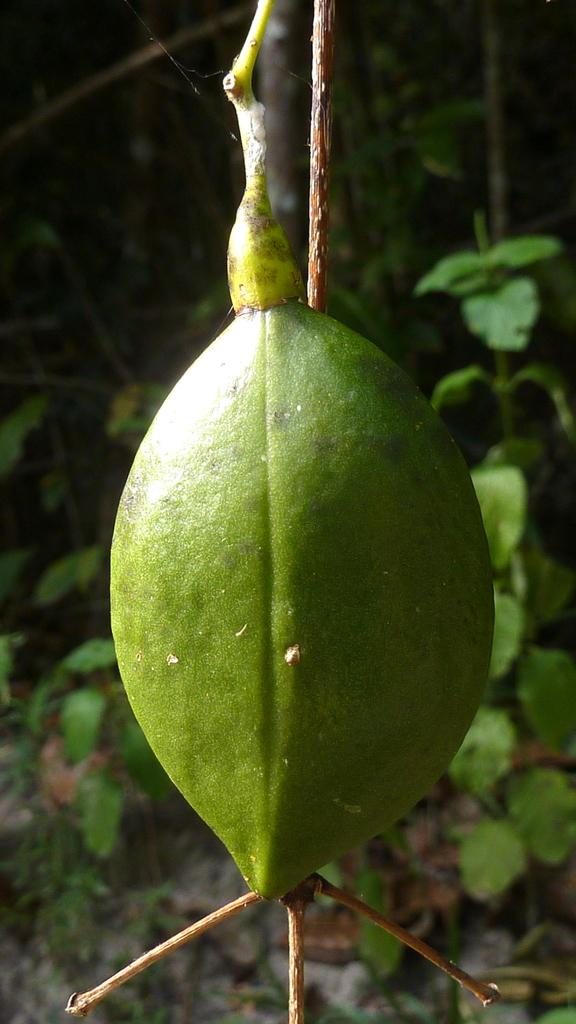What type of animal is present in the image? There is a reptile in the image. What is the reptile doing in the image? The reptile is crawling on a plant. What type of skirt is the goat wearing in the image? There is no goat or skirt present in the image. 